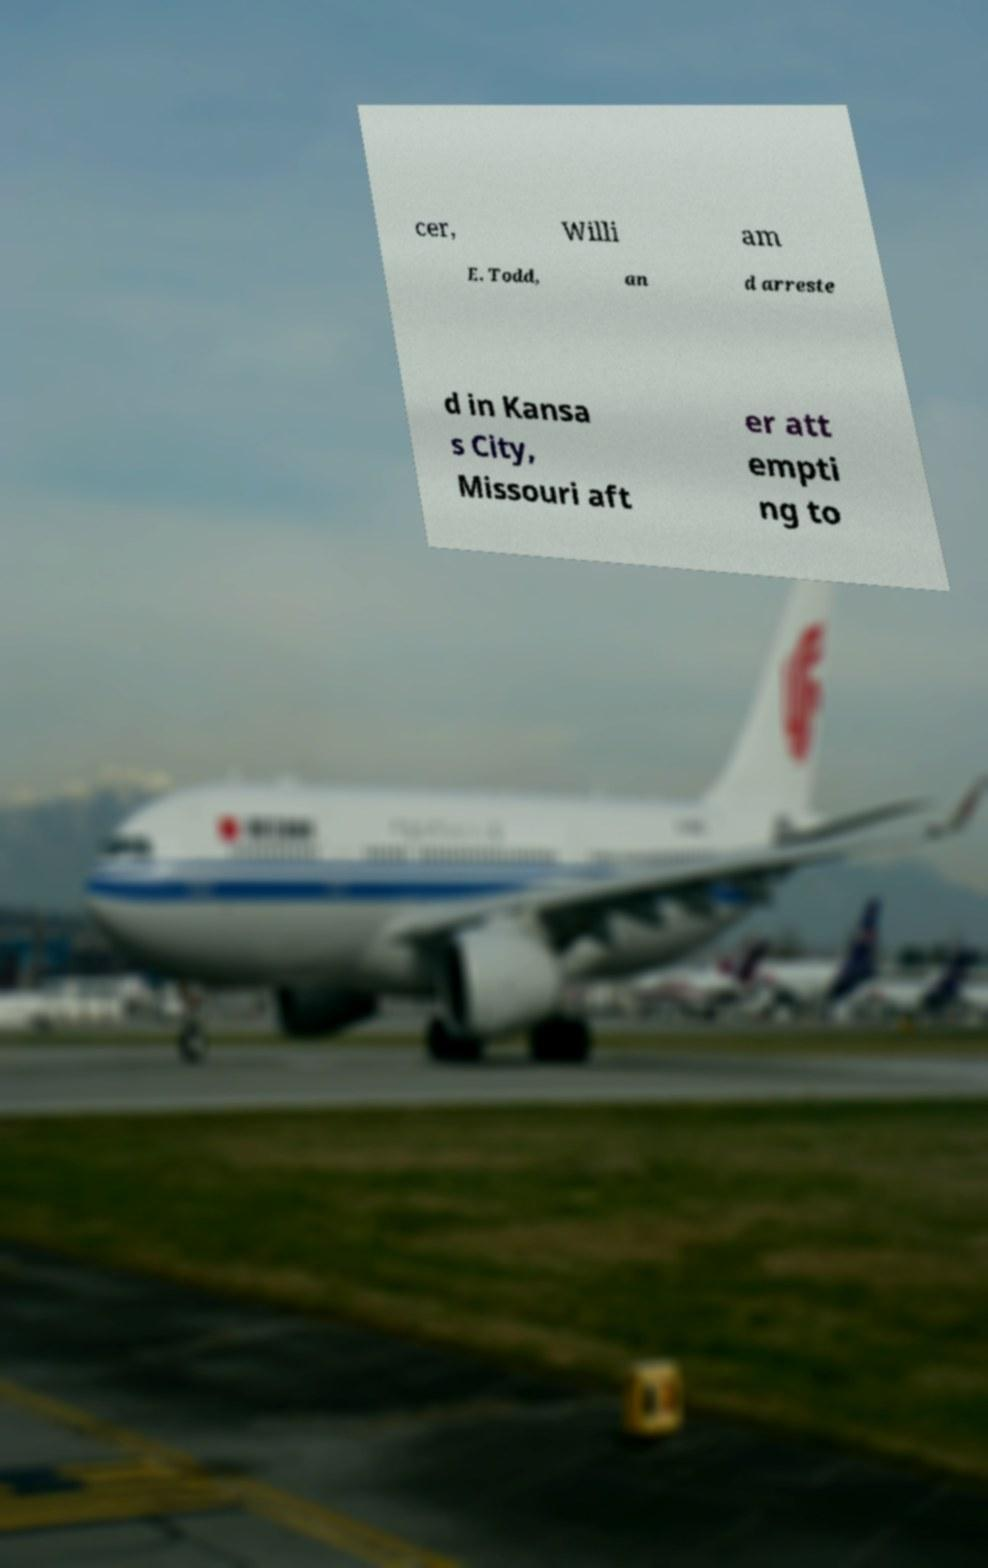Could you extract and type out the text from this image? cer, Willi am E. Todd, an d arreste d in Kansa s City, Missouri aft er att empti ng to 